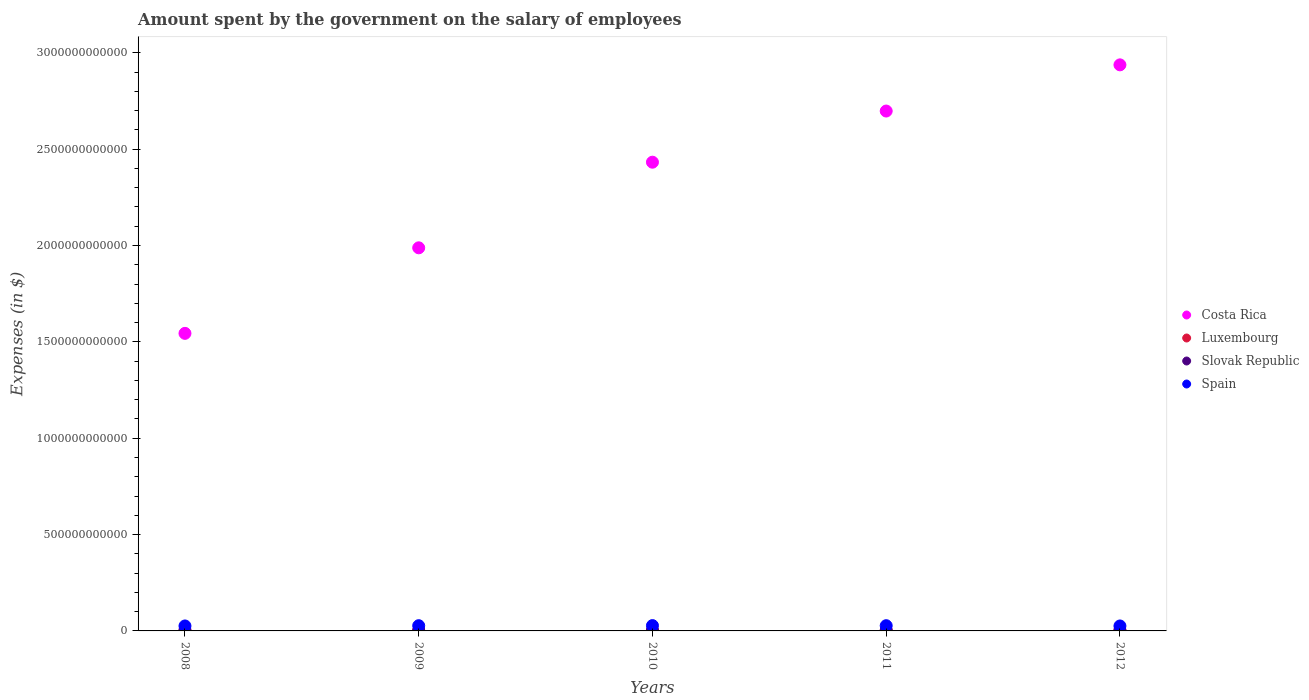Is the number of dotlines equal to the number of legend labels?
Your response must be concise. Yes. What is the amount spent on the salary of employees by the government in Spain in 2009?
Your response must be concise. 2.71e+1. Across all years, what is the maximum amount spent on the salary of employees by the government in Spain?
Your answer should be compact. 2.76e+1. Across all years, what is the minimum amount spent on the salary of employees by the government in Luxembourg?
Your answer should be very brief. 2.15e+09. In which year was the amount spent on the salary of employees by the government in Costa Rica maximum?
Give a very brief answer. 2012. What is the total amount spent on the salary of employees by the government in Slovak Republic in the graph?
Give a very brief answer. 1.47e+1. What is the difference between the amount spent on the salary of employees by the government in Spain in 2008 and that in 2009?
Provide a succinct answer. -1.32e+09. What is the difference between the amount spent on the salary of employees by the government in Spain in 2010 and the amount spent on the salary of employees by the government in Slovak Republic in 2009?
Keep it short and to the point. 2.46e+1. What is the average amount spent on the salary of employees by the government in Costa Rica per year?
Your response must be concise. 2.32e+12. In the year 2008, what is the difference between the amount spent on the salary of employees by the government in Luxembourg and amount spent on the salary of employees by the government in Spain?
Provide a short and direct response. -2.37e+1. What is the ratio of the amount spent on the salary of employees by the government in Luxembourg in 2010 to that in 2011?
Make the answer very short. 0.94. Is the amount spent on the salary of employees by the government in Luxembourg in 2010 less than that in 2012?
Provide a succinct answer. Yes. What is the difference between the highest and the second highest amount spent on the salary of employees by the government in Slovak Republic?
Your answer should be compact. 4.21e+07. What is the difference between the highest and the lowest amount spent on the salary of employees by the government in Slovak Republic?
Provide a short and direct response. 2.11e+08. In how many years, is the amount spent on the salary of employees by the government in Luxembourg greater than the average amount spent on the salary of employees by the government in Luxembourg taken over all years?
Keep it short and to the point. 3. Is the sum of the amount spent on the salary of employees by the government in Costa Rica in 2009 and 2011 greater than the maximum amount spent on the salary of employees by the government in Luxembourg across all years?
Offer a terse response. Yes. Is it the case that in every year, the sum of the amount spent on the salary of employees by the government in Luxembourg and amount spent on the salary of employees by the government in Slovak Republic  is greater than the sum of amount spent on the salary of employees by the government in Spain and amount spent on the salary of employees by the government in Costa Rica?
Offer a very short reply. No. Is it the case that in every year, the sum of the amount spent on the salary of employees by the government in Costa Rica and amount spent on the salary of employees by the government in Luxembourg  is greater than the amount spent on the salary of employees by the government in Spain?
Your answer should be compact. Yes. Is the amount spent on the salary of employees by the government in Spain strictly greater than the amount spent on the salary of employees by the government in Costa Rica over the years?
Give a very brief answer. No. Is the amount spent on the salary of employees by the government in Costa Rica strictly less than the amount spent on the salary of employees by the government in Spain over the years?
Your response must be concise. No. What is the difference between two consecutive major ticks on the Y-axis?
Offer a very short reply. 5.00e+11. Are the values on the major ticks of Y-axis written in scientific E-notation?
Make the answer very short. No. Does the graph contain any zero values?
Offer a very short reply. No. Does the graph contain grids?
Your answer should be compact. No. Where does the legend appear in the graph?
Ensure brevity in your answer.  Center right. How are the legend labels stacked?
Your answer should be compact. Vertical. What is the title of the graph?
Provide a short and direct response. Amount spent by the government on the salary of employees. Does "Madagascar" appear as one of the legend labels in the graph?
Offer a very short reply. No. What is the label or title of the X-axis?
Offer a very short reply. Years. What is the label or title of the Y-axis?
Provide a succinct answer. Expenses (in $). What is the Expenses (in $) of Costa Rica in 2008?
Provide a short and direct response. 1.54e+12. What is the Expenses (in $) of Luxembourg in 2008?
Give a very brief answer. 2.15e+09. What is the Expenses (in $) of Slovak Republic in 2008?
Ensure brevity in your answer.  2.82e+09. What is the Expenses (in $) in Spain in 2008?
Give a very brief answer. 2.58e+1. What is the Expenses (in $) of Costa Rica in 2009?
Provide a short and direct response. 1.99e+12. What is the Expenses (in $) in Luxembourg in 2009?
Your answer should be very brief. 2.34e+09. What is the Expenses (in $) in Slovak Republic in 2009?
Your answer should be very brief. 2.96e+09. What is the Expenses (in $) of Spain in 2009?
Provide a succinct answer. 2.71e+1. What is the Expenses (in $) in Costa Rica in 2010?
Provide a succinct answer. 2.43e+12. What is the Expenses (in $) of Luxembourg in 2010?
Provide a succinct answer. 2.53e+09. What is the Expenses (in $) in Slovak Republic in 2010?
Provide a short and direct response. 2.91e+09. What is the Expenses (in $) of Spain in 2010?
Provide a succinct answer. 2.76e+1. What is the Expenses (in $) of Costa Rica in 2011?
Give a very brief answer. 2.70e+12. What is the Expenses (in $) in Luxembourg in 2011?
Your answer should be compact. 2.68e+09. What is the Expenses (in $) in Slovak Republic in 2011?
Your answer should be compact. 2.98e+09. What is the Expenses (in $) of Spain in 2011?
Make the answer very short. 2.71e+1. What is the Expenses (in $) in Costa Rica in 2012?
Your answer should be very brief. 2.94e+12. What is the Expenses (in $) in Luxembourg in 2012?
Provide a short and direct response. 2.84e+09. What is the Expenses (in $) in Slovak Republic in 2012?
Provide a succinct answer. 3.03e+09. What is the Expenses (in $) in Spain in 2012?
Keep it short and to the point. 2.58e+1. Across all years, what is the maximum Expenses (in $) in Costa Rica?
Offer a terse response. 2.94e+12. Across all years, what is the maximum Expenses (in $) of Luxembourg?
Give a very brief answer. 2.84e+09. Across all years, what is the maximum Expenses (in $) in Slovak Republic?
Your answer should be compact. 3.03e+09. Across all years, what is the maximum Expenses (in $) in Spain?
Offer a very short reply. 2.76e+1. Across all years, what is the minimum Expenses (in $) in Costa Rica?
Offer a very short reply. 1.54e+12. Across all years, what is the minimum Expenses (in $) of Luxembourg?
Provide a short and direct response. 2.15e+09. Across all years, what is the minimum Expenses (in $) in Slovak Republic?
Keep it short and to the point. 2.82e+09. Across all years, what is the minimum Expenses (in $) in Spain?
Offer a terse response. 2.58e+1. What is the total Expenses (in $) in Costa Rica in the graph?
Offer a terse response. 1.16e+13. What is the total Expenses (in $) of Luxembourg in the graph?
Your answer should be compact. 1.25e+1. What is the total Expenses (in $) in Slovak Republic in the graph?
Provide a succinct answer. 1.47e+1. What is the total Expenses (in $) of Spain in the graph?
Keep it short and to the point. 1.33e+11. What is the difference between the Expenses (in $) of Costa Rica in 2008 and that in 2009?
Your response must be concise. -4.44e+11. What is the difference between the Expenses (in $) in Luxembourg in 2008 and that in 2009?
Your answer should be very brief. -1.88e+08. What is the difference between the Expenses (in $) in Slovak Republic in 2008 and that in 2009?
Your answer should be compact. -1.39e+08. What is the difference between the Expenses (in $) in Spain in 2008 and that in 2009?
Your response must be concise. -1.32e+09. What is the difference between the Expenses (in $) in Costa Rica in 2008 and that in 2010?
Provide a short and direct response. -8.88e+11. What is the difference between the Expenses (in $) of Luxembourg in 2008 and that in 2010?
Ensure brevity in your answer.  -3.83e+08. What is the difference between the Expenses (in $) of Slovak Republic in 2008 and that in 2010?
Offer a terse response. -9.27e+07. What is the difference between the Expenses (in $) of Spain in 2008 and that in 2010?
Give a very brief answer. -1.78e+09. What is the difference between the Expenses (in $) of Costa Rica in 2008 and that in 2011?
Keep it short and to the point. -1.15e+12. What is the difference between the Expenses (in $) of Luxembourg in 2008 and that in 2011?
Your response must be concise. -5.33e+08. What is the difference between the Expenses (in $) of Slovak Republic in 2008 and that in 2011?
Your response must be concise. -1.68e+08. What is the difference between the Expenses (in $) of Spain in 2008 and that in 2011?
Your answer should be compact. -1.32e+09. What is the difference between the Expenses (in $) of Costa Rica in 2008 and that in 2012?
Your answer should be compact. -1.39e+12. What is the difference between the Expenses (in $) in Luxembourg in 2008 and that in 2012?
Offer a terse response. -6.96e+08. What is the difference between the Expenses (in $) of Slovak Republic in 2008 and that in 2012?
Your answer should be compact. -2.11e+08. What is the difference between the Expenses (in $) in Spain in 2008 and that in 2012?
Offer a terse response. 6.30e+07. What is the difference between the Expenses (in $) of Costa Rica in 2009 and that in 2010?
Ensure brevity in your answer.  -4.44e+11. What is the difference between the Expenses (in $) in Luxembourg in 2009 and that in 2010?
Your answer should be very brief. -1.96e+08. What is the difference between the Expenses (in $) in Slovak Republic in 2009 and that in 2010?
Make the answer very short. 4.65e+07. What is the difference between the Expenses (in $) in Spain in 2009 and that in 2010?
Offer a terse response. -4.54e+08. What is the difference between the Expenses (in $) in Costa Rica in 2009 and that in 2011?
Offer a terse response. -7.10e+11. What is the difference between the Expenses (in $) of Luxembourg in 2009 and that in 2011?
Keep it short and to the point. -3.45e+08. What is the difference between the Expenses (in $) of Slovak Republic in 2009 and that in 2011?
Give a very brief answer. -2.92e+07. What is the difference between the Expenses (in $) in Spain in 2009 and that in 2011?
Provide a short and direct response. 9.00e+06. What is the difference between the Expenses (in $) of Costa Rica in 2009 and that in 2012?
Offer a very short reply. -9.49e+11. What is the difference between the Expenses (in $) in Luxembourg in 2009 and that in 2012?
Keep it short and to the point. -5.08e+08. What is the difference between the Expenses (in $) of Slovak Republic in 2009 and that in 2012?
Provide a succinct answer. -7.13e+07. What is the difference between the Expenses (in $) in Spain in 2009 and that in 2012?
Provide a succinct answer. 1.39e+09. What is the difference between the Expenses (in $) in Costa Rica in 2010 and that in 2011?
Offer a very short reply. -2.65e+11. What is the difference between the Expenses (in $) in Luxembourg in 2010 and that in 2011?
Ensure brevity in your answer.  -1.49e+08. What is the difference between the Expenses (in $) of Slovak Republic in 2010 and that in 2011?
Your answer should be compact. -7.57e+07. What is the difference between the Expenses (in $) in Spain in 2010 and that in 2011?
Your answer should be compact. 4.63e+08. What is the difference between the Expenses (in $) of Costa Rica in 2010 and that in 2012?
Offer a terse response. -5.05e+11. What is the difference between the Expenses (in $) of Luxembourg in 2010 and that in 2012?
Give a very brief answer. -3.12e+08. What is the difference between the Expenses (in $) in Slovak Republic in 2010 and that in 2012?
Your answer should be compact. -1.18e+08. What is the difference between the Expenses (in $) in Spain in 2010 and that in 2012?
Your answer should be very brief. 1.84e+09. What is the difference between the Expenses (in $) of Costa Rica in 2011 and that in 2012?
Provide a short and direct response. -2.40e+11. What is the difference between the Expenses (in $) of Luxembourg in 2011 and that in 2012?
Offer a very short reply. -1.63e+08. What is the difference between the Expenses (in $) in Slovak Republic in 2011 and that in 2012?
Keep it short and to the point. -4.21e+07. What is the difference between the Expenses (in $) in Spain in 2011 and that in 2012?
Make the answer very short. 1.38e+09. What is the difference between the Expenses (in $) of Costa Rica in 2008 and the Expenses (in $) of Luxembourg in 2009?
Provide a succinct answer. 1.54e+12. What is the difference between the Expenses (in $) in Costa Rica in 2008 and the Expenses (in $) in Slovak Republic in 2009?
Your answer should be compact. 1.54e+12. What is the difference between the Expenses (in $) in Costa Rica in 2008 and the Expenses (in $) in Spain in 2009?
Ensure brevity in your answer.  1.52e+12. What is the difference between the Expenses (in $) of Luxembourg in 2008 and the Expenses (in $) of Slovak Republic in 2009?
Offer a very short reply. -8.07e+08. What is the difference between the Expenses (in $) of Luxembourg in 2008 and the Expenses (in $) of Spain in 2009?
Ensure brevity in your answer.  -2.50e+1. What is the difference between the Expenses (in $) of Slovak Republic in 2008 and the Expenses (in $) of Spain in 2009?
Provide a succinct answer. -2.43e+1. What is the difference between the Expenses (in $) of Costa Rica in 2008 and the Expenses (in $) of Luxembourg in 2010?
Make the answer very short. 1.54e+12. What is the difference between the Expenses (in $) of Costa Rica in 2008 and the Expenses (in $) of Slovak Republic in 2010?
Keep it short and to the point. 1.54e+12. What is the difference between the Expenses (in $) of Costa Rica in 2008 and the Expenses (in $) of Spain in 2010?
Offer a terse response. 1.52e+12. What is the difference between the Expenses (in $) of Luxembourg in 2008 and the Expenses (in $) of Slovak Republic in 2010?
Ensure brevity in your answer.  -7.60e+08. What is the difference between the Expenses (in $) in Luxembourg in 2008 and the Expenses (in $) in Spain in 2010?
Your response must be concise. -2.55e+1. What is the difference between the Expenses (in $) of Slovak Republic in 2008 and the Expenses (in $) of Spain in 2010?
Your answer should be very brief. -2.48e+1. What is the difference between the Expenses (in $) of Costa Rica in 2008 and the Expenses (in $) of Luxembourg in 2011?
Your response must be concise. 1.54e+12. What is the difference between the Expenses (in $) in Costa Rica in 2008 and the Expenses (in $) in Slovak Republic in 2011?
Offer a terse response. 1.54e+12. What is the difference between the Expenses (in $) in Costa Rica in 2008 and the Expenses (in $) in Spain in 2011?
Offer a terse response. 1.52e+12. What is the difference between the Expenses (in $) in Luxembourg in 2008 and the Expenses (in $) in Slovak Republic in 2011?
Ensure brevity in your answer.  -8.36e+08. What is the difference between the Expenses (in $) of Luxembourg in 2008 and the Expenses (in $) of Spain in 2011?
Give a very brief answer. -2.50e+1. What is the difference between the Expenses (in $) of Slovak Republic in 2008 and the Expenses (in $) of Spain in 2011?
Your answer should be very brief. -2.43e+1. What is the difference between the Expenses (in $) in Costa Rica in 2008 and the Expenses (in $) in Luxembourg in 2012?
Ensure brevity in your answer.  1.54e+12. What is the difference between the Expenses (in $) of Costa Rica in 2008 and the Expenses (in $) of Slovak Republic in 2012?
Your response must be concise. 1.54e+12. What is the difference between the Expenses (in $) in Costa Rica in 2008 and the Expenses (in $) in Spain in 2012?
Offer a terse response. 1.52e+12. What is the difference between the Expenses (in $) of Luxembourg in 2008 and the Expenses (in $) of Slovak Republic in 2012?
Give a very brief answer. -8.78e+08. What is the difference between the Expenses (in $) in Luxembourg in 2008 and the Expenses (in $) in Spain in 2012?
Offer a terse response. -2.36e+1. What is the difference between the Expenses (in $) of Slovak Republic in 2008 and the Expenses (in $) of Spain in 2012?
Offer a terse response. -2.29e+1. What is the difference between the Expenses (in $) of Costa Rica in 2009 and the Expenses (in $) of Luxembourg in 2010?
Offer a terse response. 1.99e+12. What is the difference between the Expenses (in $) of Costa Rica in 2009 and the Expenses (in $) of Slovak Republic in 2010?
Offer a very short reply. 1.98e+12. What is the difference between the Expenses (in $) of Costa Rica in 2009 and the Expenses (in $) of Spain in 2010?
Your answer should be very brief. 1.96e+12. What is the difference between the Expenses (in $) of Luxembourg in 2009 and the Expenses (in $) of Slovak Republic in 2010?
Offer a terse response. -5.73e+08. What is the difference between the Expenses (in $) in Luxembourg in 2009 and the Expenses (in $) in Spain in 2010?
Ensure brevity in your answer.  -2.53e+1. What is the difference between the Expenses (in $) of Slovak Republic in 2009 and the Expenses (in $) of Spain in 2010?
Provide a succinct answer. -2.46e+1. What is the difference between the Expenses (in $) in Costa Rica in 2009 and the Expenses (in $) in Luxembourg in 2011?
Your response must be concise. 1.99e+12. What is the difference between the Expenses (in $) of Costa Rica in 2009 and the Expenses (in $) of Slovak Republic in 2011?
Keep it short and to the point. 1.98e+12. What is the difference between the Expenses (in $) in Costa Rica in 2009 and the Expenses (in $) in Spain in 2011?
Offer a terse response. 1.96e+12. What is the difference between the Expenses (in $) of Luxembourg in 2009 and the Expenses (in $) of Slovak Republic in 2011?
Your response must be concise. -6.48e+08. What is the difference between the Expenses (in $) in Luxembourg in 2009 and the Expenses (in $) in Spain in 2011?
Offer a very short reply. -2.48e+1. What is the difference between the Expenses (in $) in Slovak Republic in 2009 and the Expenses (in $) in Spain in 2011?
Make the answer very short. -2.42e+1. What is the difference between the Expenses (in $) in Costa Rica in 2009 and the Expenses (in $) in Luxembourg in 2012?
Keep it short and to the point. 1.98e+12. What is the difference between the Expenses (in $) in Costa Rica in 2009 and the Expenses (in $) in Slovak Republic in 2012?
Your answer should be compact. 1.98e+12. What is the difference between the Expenses (in $) of Costa Rica in 2009 and the Expenses (in $) of Spain in 2012?
Ensure brevity in your answer.  1.96e+12. What is the difference between the Expenses (in $) in Luxembourg in 2009 and the Expenses (in $) in Slovak Republic in 2012?
Your answer should be compact. -6.91e+08. What is the difference between the Expenses (in $) in Luxembourg in 2009 and the Expenses (in $) in Spain in 2012?
Ensure brevity in your answer.  -2.34e+1. What is the difference between the Expenses (in $) in Slovak Republic in 2009 and the Expenses (in $) in Spain in 2012?
Ensure brevity in your answer.  -2.28e+1. What is the difference between the Expenses (in $) of Costa Rica in 2010 and the Expenses (in $) of Luxembourg in 2011?
Make the answer very short. 2.43e+12. What is the difference between the Expenses (in $) in Costa Rica in 2010 and the Expenses (in $) in Slovak Republic in 2011?
Keep it short and to the point. 2.43e+12. What is the difference between the Expenses (in $) in Costa Rica in 2010 and the Expenses (in $) in Spain in 2011?
Your answer should be compact. 2.40e+12. What is the difference between the Expenses (in $) in Luxembourg in 2010 and the Expenses (in $) in Slovak Republic in 2011?
Your answer should be compact. -4.53e+08. What is the difference between the Expenses (in $) in Luxembourg in 2010 and the Expenses (in $) in Spain in 2011?
Ensure brevity in your answer.  -2.46e+1. What is the difference between the Expenses (in $) in Slovak Republic in 2010 and the Expenses (in $) in Spain in 2011?
Offer a terse response. -2.42e+1. What is the difference between the Expenses (in $) in Costa Rica in 2010 and the Expenses (in $) in Luxembourg in 2012?
Offer a terse response. 2.43e+12. What is the difference between the Expenses (in $) of Costa Rica in 2010 and the Expenses (in $) of Slovak Republic in 2012?
Your answer should be very brief. 2.43e+12. What is the difference between the Expenses (in $) in Costa Rica in 2010 and the Expenses (in $) in Spain in 2012?
Ensure brevity in your answer.  2.41e+12. What is the difference between the Expenses (in $) of Luxembourg in 2010 and the Expenses (in $) of Slovak Republic in 2012?
Ensure brevity in your answer.  -4.95e+08. What is the difference between the Expenses (in $) in Luxembourg in 2010 and the Expenses (in $) in Spain in 2012?
Offer a very short reply. -2.32e+1. What is the difference between the Expenses (in $) in Slovak Republic in 2010 and the Expenses (in $) in Spain in 2012?
Your response must be concise. -2.29e+1. What is the difference between the Expenses (in $) of Costa Rica in 2011 and the Expenses (in $) of Luxembourg in 2012?
Your response must be concise. 2.69e+12. What is the difference between the Expenses (in $) in Costa Rica in 2011 and the Expenses (in $) in Slovak Republic in 2012?
Your answer should be compact. 2.69e+12. What is the difference between the Expenses (in $) of Costa Rica in 2011 and the Expenses (in $) of Spain in 2012?
Your response must be concise. 2.67e+12. What is the difference between the Expenses (in $) of Luxembourg in 2011 and the Expenses (in $) of Slovak Republic in 2012?
Make the answer very short. -3.46e+08. What is the difference between the Expenses (in $) in Luxembourg in 2011 and the Expenses (in $) in Spain in 2012?
Your answer should be compact. -2.31e+1. What is the difference between the Expenses (in $) of Slovak Republic in 2011 and the Expenses (in $) of Spain in 2012?
Offer a very short reply. -2.28e+1. What is the average Expenses (in $) of Costa Rica per year?
Your answer should be compact. 2.32e+12. What is the average Expenses (in $) of Luxembourg per year?
Your answer should be very brief. 2.51e+09. What is the average Expenses (in $) in Slovak Republic per year?
Offer a terse response. 2.94e+09. What is the average Expenses (in $) in Spain per year?
Your answer should be compact. 2.67e+1. In the year 2008, what is the difference between the Expenses (in $) in Costa Rica and Expenses (in $) in Luxembourg?
Your answer should be compact. 1.54e+12. In the year 2008, what is the difference between the Expenses (in $) of Costa Rica and Expenses (in $) of Slovak Republic?
Provide a short and direct response. 1.54e+12. In the year 2008, what is the difference between the Expenses (in $) in Costa Rica and Expenses (in $) in Spain?
Ensure brevity in your answer.  1.52e+12. In the year 2008, what is the difference between the Expenses (in $) in Luxembourg and Expenses (in $) in Slovak Republic?
Offer a terse response. -6.68e+08. In the year 2008, what is the difference between the Expenses (in $) in Luxembourg and Expenses (in $) in Spain?
Keep it short and to the point. -2.37e+1. In the year 2008, what is the difference between the Expenses (in $) in Slovak Republic and Expenses (in $) in Spain?
Keep it short and to the point. -2.30e+1. In the year 2009, what is the difference between the Expenses (in $) in Costa Rica and Expenses (in $) in Luxembourg?
Make the answer very short. 1.99e+12. In the year 2009, what is the difference between the Expenses (in $) of Costa Rica and Expenses (in $) of Slovak Republic?
Give a very brief answer. 1.98e+12. In the year 2009, what is the difference between the Expenses (in $) in Costa Rica and Expenses (in $) in Spain?
Provide a short and direct response. 1.96e+12. In the year 2009, what is the difference between the Expenses (in $) of Luxembourg and Expenses (in $) of Slovak Republic?
Provide a succinct answer. -6.19e+08. In the year 2009, what is the difference between the Expenses (in $) of Luxembourg and Expenses (in $) of Spain?
Keep it short and to the point. -2.48e+1. In the year 2009, what is the difference between the Expenses (in $) in Slovak Republic and Expenses (in $) in Spain?
Offer a terse response. -2.42e+1. In the year 2010, what is the difference between the Expenses (in $) in Costa Rica and Expenses (in $) in Luxembourg?
Make the answer very short. 2.43e+12. In the year 2010, what is the difference between the Expenses (in $) of Costa Rica and Expenses (in $) of Slovak Republic?
Provide a succinct answer. 2.43e+12. In the year 2010, what is the difference between the Expenses (in $) of Costa Rica and Expenses (in $) of Spain?
Provide a succinct answer. 2.40e+12. In the year 2010, what is the difference between the Expenses (in $) of Luxembourg and Expenses (in $) of Slovak Republic?
Ensure brevity in your answer.  -3.77e+08. In the year 2010, what is the difference between the Expenses (in $) in Luxembourg and Expenses (in $) in Spain?
Offer a terse response. -2.51e+1. In the year 2010, what is the difference between the Expenses (in $) in Slovak Republic and Expenses (in $) in Spain?
Ensure brevity in your answer.  -2.47e+1. In the year 2011, what is the difference between the Expenses (in $) of Costa Rica and Expenses (in $) of Luxembourg?
Ensure brevity in your answer.  2.69e+12. In the year 2011, what is the difference between the Expenses (in $) in Costa Rica and Expenses (in $) in Slovak Republic?
Offer a very short reply. 2.69e+12. In the year 2011, what is the difference between the Expenses (in $) of Costa Rica and Expenses (in $) of Spain?
Provide a succinct answer. 2.67e+12. In the year 2011, what is the difference between the Expenses (in $) of Luxembourg and Expenses (in $) of Slovak Republic?
Your response must be concise. -3.04e+08. In the year 2011, what is the difference between the Expenses (in $) of Luxembourg and Expenses (in $) of Spain?
Offer a terse response. -2.45e+1. In the year 2011, what is the difference between the Expenses (in $) in Slovak Republic and Expenses (in $) in Spain?
Offer a very short reply. -2.42e+1. In the year 2012, what is the difference between the Expenses (in $) in Costa Rica and Expenses (in $) in Luxembourg?
Provide a short and direct response. 2.93e+12. In the year 2012, what is the difference between the Expenses (in $) of Costa Rica and Expenses (in $) of Slovak Republic?
Your answer should be very brief. 2.93e+12. In the year 2012, what is the difference between the Expenses (in $) in Costa Rica and Expenses (in $) in Spain?
Your response must be concise. 2.91e+12. In the year 2012, what is the difference between the Expenses (in $) in Luxembourg and Expenses (in $) in Slovak Republic?
Offer a terse response. -1.83e+08. In the year 2012, what is the difference between the Expenses (in $) in Luxembourg and Expenses (in $) in Spain?
Offer a very short reply. -2.29e+1. In the year 2012, what is the difference between the Expenses (in $) of Slovak Republic and Expenses (in $) of Spain?
Offer a terse response. -2.27e+1. What is the ratio of the Expenses (in $) in Costa Rica in 2008 to that in 2009?
Keep it short and to the point. 0.78. What is the ratio of the Expenses (in $) in Luxembourg in 2008 to that in 2009?
Your response must be concise. 0.92. What is the ratio of the Expenses (in $) of Slovak Republic in 2008 to that in 2009?
Ensure brevity in your answer.  0.95. What is the ratio of the Expenses (in $) of Spain in 2008 to that in 2009?
Keep it short and to the point. 0.95. What is the ratio of the Expenses (in $) of Costa Rica in 2008 to that in 2010?
Your answer should be compact. 0.63. What is the ratio of the Expenses (in $) of Luxembourg in 2008 to that in 2010?
Make the answer very short. 0.85. What is the ratio of the Expenses (in $) in Slovak Republic in 2008 to that in 2010?
Give a very brief answer. 0.97. What is the ratio of the Expenses (in $) of Spain in 2008 to that in 2010?
Give a very brief answer. 0.94. What is the ratio of the Expenses (in $) of Costa Rica in 2008 to that in 2011?
Provide a succinct answer. 0.57. What is the ratio of the Expenses (in $) in Luxembourg in 2008 to that in 2011?
Keep it short and to the point. 0.8. What is the ratio of the Expenses (in $) of Slovak Republic in 2008 to that in 2011?
Offer a terse response. 0.94. What is the ratio of the Expenses (in $) in Spain in 2008 to that in 2011?
Provide a succinct answer. 0.95. What is the ratio of the Expenses (in $) of Costa Rica in 2008 to that in 2012?
Offer a very short reply. 0.53. What is the ratio of the Expenses (in $) in Luxembourg in 2008 to that in 2012?
Provide a succinct answer. 0.76. What is the ratio of the Expenses (in $) of Slovak Republic in 2008 to that in 2012?
Your response must be concise. 0.93. What is the ratio of the Expenses (in $) of Costa Rica in 2009 to that in 2010?
Give a very brief answer. 0.82. What is the ratio of the Expenses (in $) of Luxembourg in 2009 to that in 2010?
Provide a short and direct response. 0.92. What is the ratio of the Expenses (in $) of Slovak Republic in 2009 to that in 2010?
Make the answer very short. 1.02. What is the ratio of the Expenses (in $) in Spain in 2009 to that in 2010?
Give a very brief answer. 0.98. What is the ratio of the Expenses (in $) in Costa Rica in 2009 to that in 2011?
Your answer should be compact. 0.74. What is the ratio of the Expenses (in $) of Luxembourg in 2009 to that in 2011?
Keep it short and to the point. 0.87. What is the ratio of the Expenses (in $) in Slovak Republic in 2009 to that in 2011?
Provide a succinct answer. 0.99. What is the ratio of the Expenses (in $) in Costa Rica in 2009 to that in 2012?
Ensure brevity in your answer.  0.68. What is the ratio of the Expenses (in $) of Luxembourg in 2009 to that in 2012?
Provide a succinct answer. 0.82. What is the ratio of the Expenses (in $) of Slovak Republic in 2009 to that in 2012?
Your answer should be compact. 0.98. What is the ratio of the Expenses (in $) of Spain in 2009 to that in 2012?
Keep it short and to the point. 1.05. What is the ratio of the Expenses (in $) of Costa Rica in 2010 to that in 2011?
Ensure brevity in your answer.  0.9. What is the ratio of the Expenses (in $) of Luxembourg in 2010 to that in 2011?
Offer a very short reply. 0.94. What is the ratio of the Expenses (in $) of Slovak Republic in 2010 to that in 2011?
Your answer should be very brief. 0.97. What is the ratio of the Expenses (in $) in Spain in 2010 to that in 2011?
Keep it short and to the point. 1.02. What is the ratio of the Expenses (in $) in Costa Rica in 2010 to that in 2012?
Keep it short and to the point. 0.83. What is the ratio of the Expenses (in $) of Luxembourg in 2010 to that in 2012?
Your answer should be very brief. 0.89. What is the ratio of the Expenses (in $) in Slovak Republic in 2010 to that in 2012?
Give a very brief answer. 0.96. What is the ratio of the Expenses (in $) in Spain in 2010 to that in 2012?
Offer a very short reply. 1.07. What is the ratio of the Expenses (in $) of Costa Rica in 2011 to that in 2012?
Offer a terse response. 0.92. What is the ratio of the Expenses (in $) in Luxembourg in 2011 to that in 2012?
Give a very brief answer. 0.94. What is the ratio of the Expenses (in $) in Slovak Republic in 2011 to that in 2012?
Your answer should be compact. 0.99. What is the ratio of the Expenses (in $) of Spain in 2011 to that in 2012?
Make the answer very short. 1.05. What is the difference between the highest and the second highest Expenses (in $) of Costa Rica?
Your response must be concise. 2.40e+11. What is the difference between the highest and the second highest Expenses (in $) in Luxembourg?
Your answer should be compact. 1.63e+08. What is the difference between the highest and the second highest Expenses (in $) in Slovak Republic?
Ensure brevity in your answer.  4.21e+07. What is the difference between the highest and the second highest Expenses (in $) of Spain?
Your answer should be compact. 4.54e+08. What is the difference between the highest and the lowest Expenses (in $) in Costa Rica?
Keep it short and to the point. 1.39e+12. What is the difference between the highest and the lowest Expenses (in $) of Luxembourg?
Your response must be concise. 6.96e+08. What is the difference between the highest and the lowest Expenses (in $) of Slovak Republic?
Provide a short and direct response. 2.11e+08. What is the difference between the highest and the lowest Expenses (in $) in Spain?
Your response must be concise. 1.84e+09. 